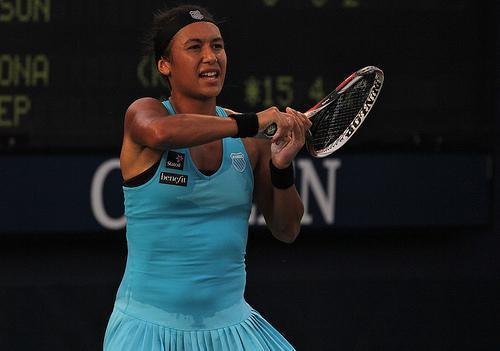How many people are there?
Give a very brief answer. 1. How many of th letters on the wall behind the tennis player are the letter "a"?
Give a very brief answer. 1. 